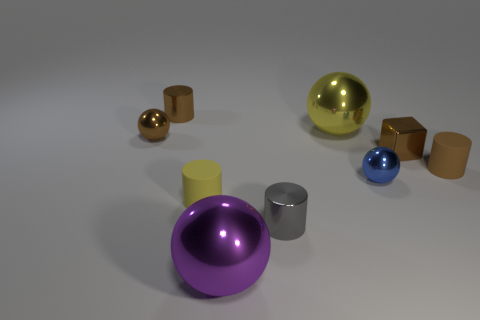Subtract 1 balls. How many balls are left? 3 Subtract all cubes. How many objects are left? 8 Subtract 1 brown balls. How many objects are left? 8 Subtract all yellow metal spheres. Subtract all yellow spheres. How many objects are left? 7 Add 6 small brown metal things. How many small brown metal things are left? 9 Add 4 small brown objects. How many small brown objects exist? 8 